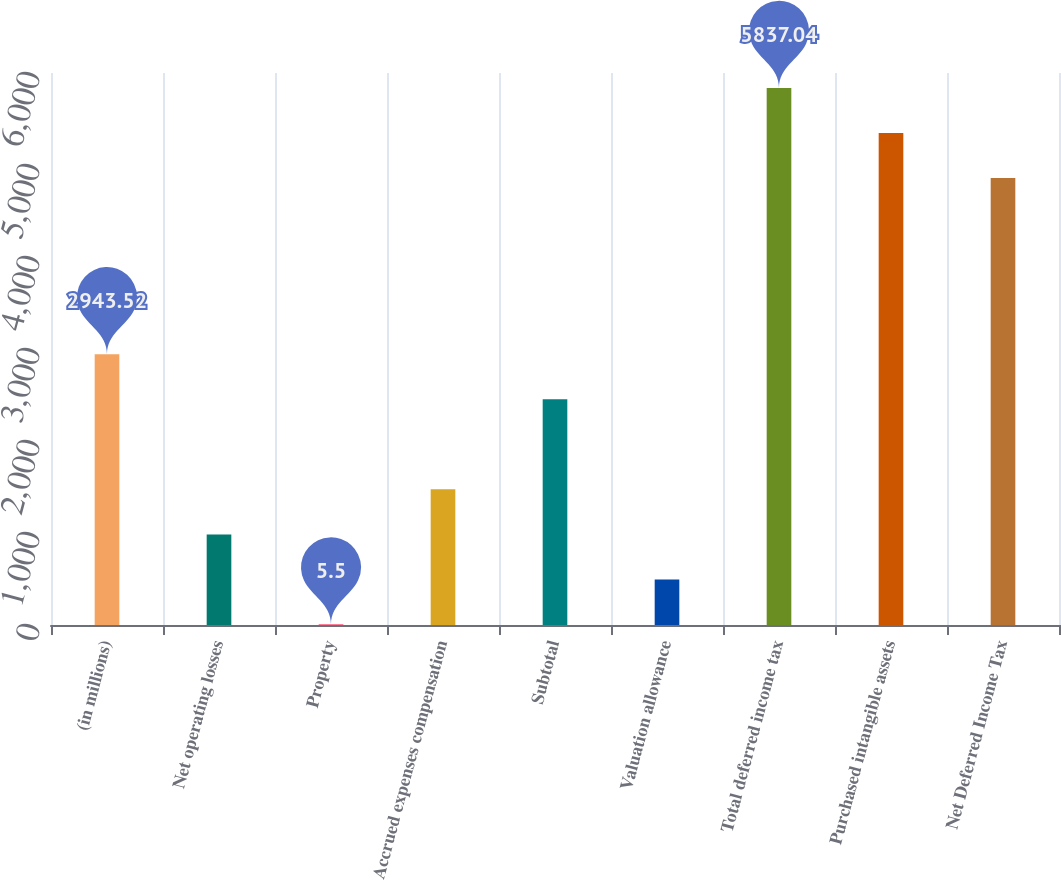<chart> <loc_0><loc_0><loc_500><loc_500><bar_chart><fcel>(in millions)<fcel>Net operating losses<fcel>Property<fcel>Accrued expenses compensation<fcel>Subtotal<fcel>Valuation allowance<fcel>Total deferred income tax<fcel>Purchased intangible assets<fcel>Net Deferred Income Tax<nl><fcel>2943.52<fcel>984.84<fcel>5.5<fcel>1474.51<fcel>2453.85<fcel>495.17<fcel>5837.04<fcel>5347.37<fcel>4857.7<nl></chart> 